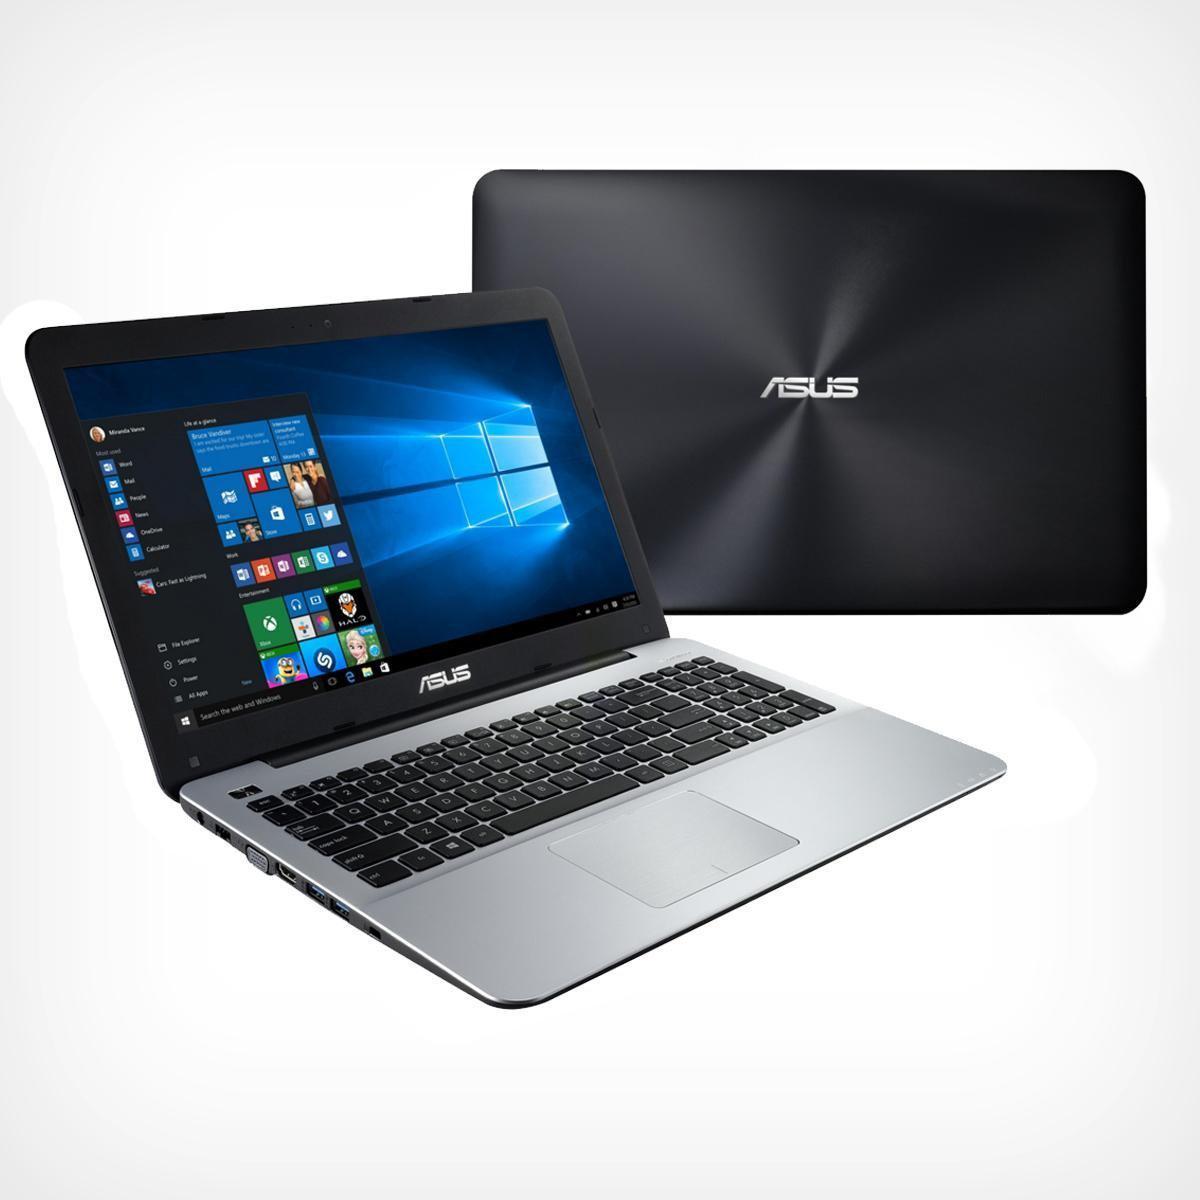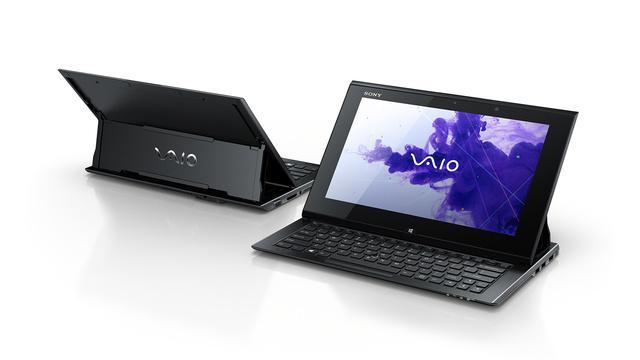The first image is the image on the left, the second image is the image on the right. Assess this claim about the two images: "One image contains only one laptop and the other image contains one open laptop and one closed laptop.". Correct or not? Answer yes or no. No. The first image is the image on the left, the second image is the image on the right. Given the left and right images, does the statement "The left image features an open, rightward facing laptop overlapping an upright closed silver laptop, and the right image contains only an open, rightward facing laptop." hold true? Answer yes or no. No. 